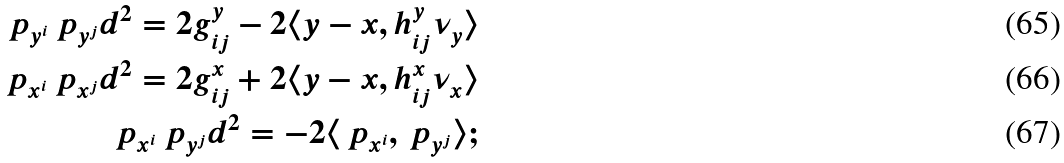Convert formula to latex. <formula><loc_0><loc_0><loc_500><loc_500>\ p _ { y ^ { i } } \ p _ { y ^ { j } } d ^ { 2 } = 2 g _ { i j } ^ { y } - 2 \langle y - x , h _ { i j } ^ { y } \nu _ { y } \rangle \\ \ p _ { x ^ { i } } \ p _ { x ^ { j } } d ^ { 2 } = 2 g _ { i j } ^ { x } + 2 \langle y - x , h _ { i j } ^ { x } \nu _ { x } \rangle \\ \ p _ { x ^ { i } } \ p _ { y ^ { j } } d ^ { 2 } = - 2 \langle \ p _ { x ^ { i } } , \ p _ { y ^ { j } } \rangle ;</formula> 